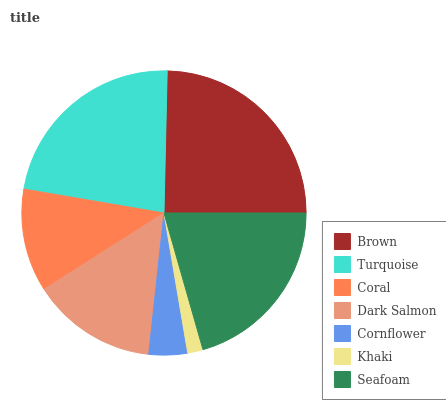Is Khaki the minimum?
Answer yes or no. Yes. Is Brown the maximum?
Answer yes or no. Yes. Is Turquoise the minimum?
Answer yes or no. No. Is Turquoise the maximum?
Answer yes or no. No. Is Brown greater than Turquoise?
Answer yes or no. Yes. Is Turquoise less than Brown?
Answer yes or no. Yes. Is Turquoise greater than Brown?
Answer yes or no. No. Is Brown less than Turquoise?
Answer yes or no. No. Is Dark Salmon the high median?
Answer yes or no. Yes. Is Dark Salmon the low median?
Answer yes or no. Yes. Is Seafoam the high median?
Answer yes or no. No. Is Khaki the low median?
Answer yes or no. No. 